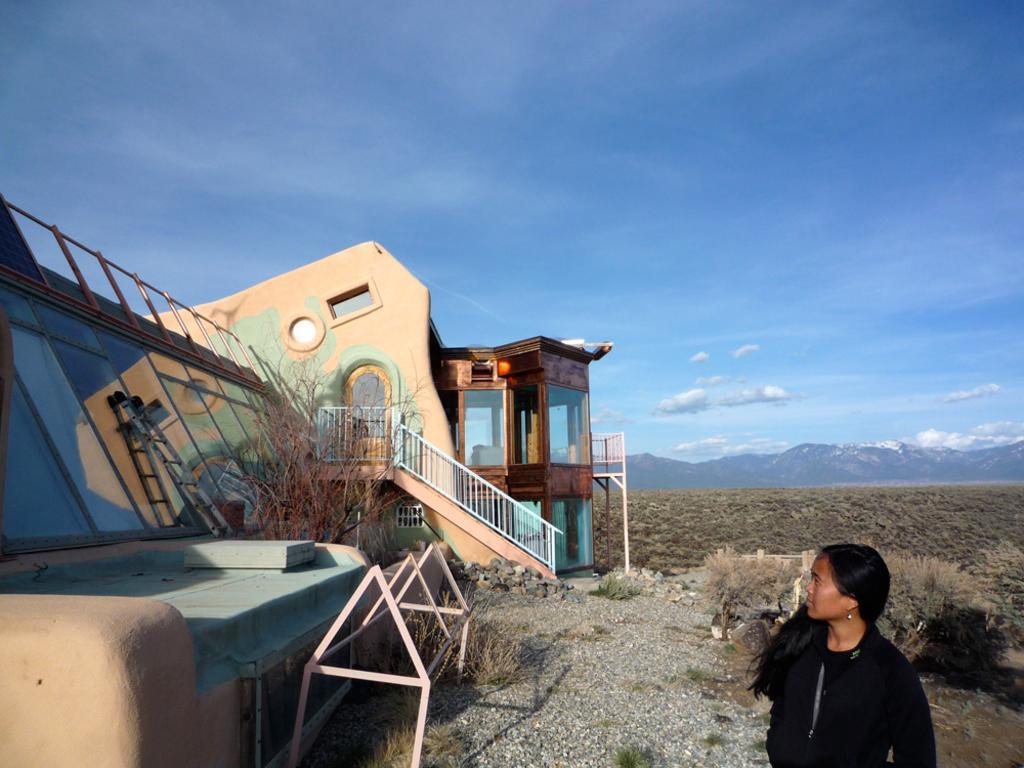Can you describe this image briefly? In the image there is a woman in black dress standing on the right side, on the left side there is a home, in the back the land is covered with dry trees followed by hills over the whole background and above its sky with clouds. 